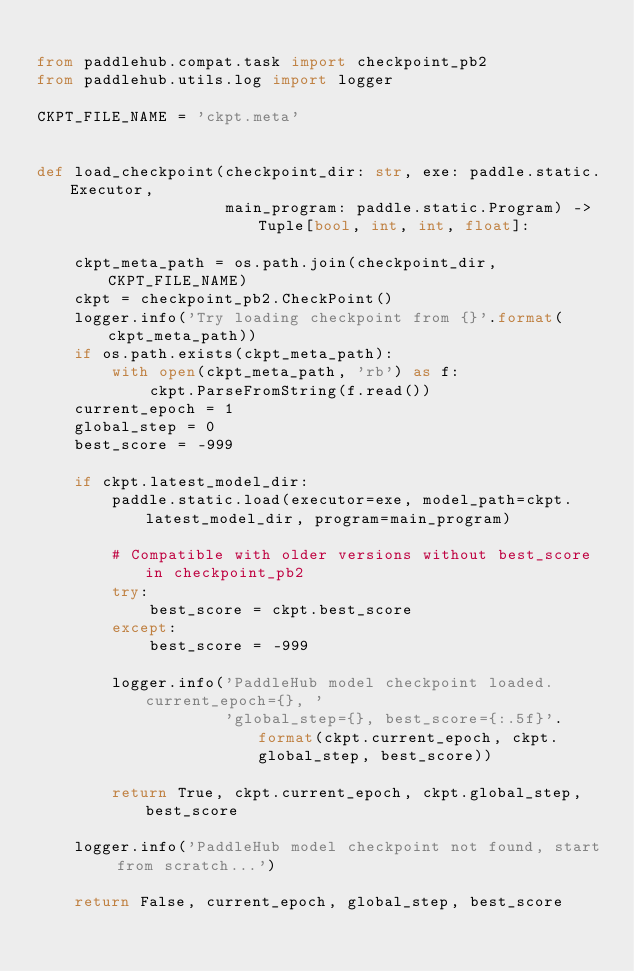<code> <loc_0><loc_0><loc_500><loc_500><_Python_>
from paddlehub.compat.task import checkpoint_pb2
from paddlehub.utils.log import logger

CKPT_FILE_NAME = 'ckpt.meta'


def load_checkpoint(checkpoint_dir: str, exe: paddle.static.Executor,
                    main_program: paddle.static.Program) -> Tuple[bool, int, int, float]:

    ckpt_meta_path = os.path.join(checkpoint_dir, CKPT_FILE_NAME)
    ckpt = checkpoint_pb2.CheckPoint()
    logger.info('Try loading checkpoint from {}'.format(ckpt_meta_path))
    if os.path.exists(ckpt_meta_path):
        with open(ckpt_meta_path, 'rb') as f:
            ckpt.ParseFromString(f.read())
    current_epoch = 1
    global_step = 0
    best_score = -999

    if ckpt.latest_model_dir:
        paddle.static.load(executor=exe, model_path=ckpt.latest_model_dir, program=main_program)

        # Compatible with older versions without best_score in checkpoint_pb2
        try:
            best_score = ckpt.best_score
        except:
            best_score = -999

        logger.info('PaddleHub model checkpoint loaded. current_epoch={}, '
                    'global_step={}, best_score={:.5f}'.format(ckpt.current_epoch, ckpt.global_step, best_score))

        return True, ckpt.current_epoch, ckpt.global_step, best_score

    logger.info('PaddleHub model checkpoint not found, start from scratch...')

    return False, current_epoch, global_step, best_score
</code> 